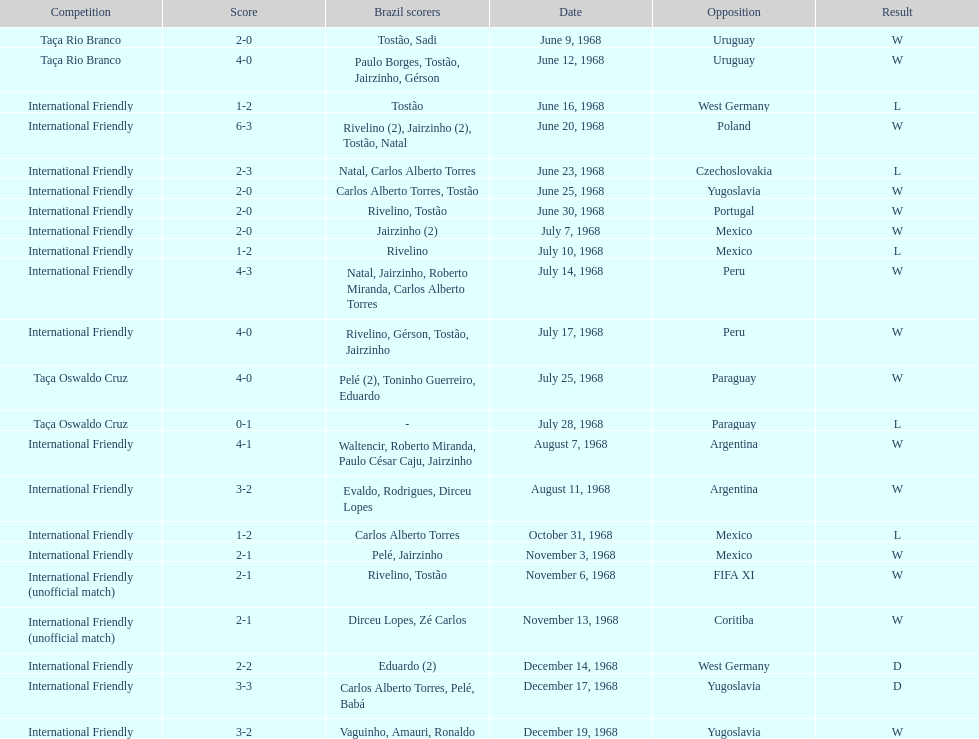The most goals scored by brazil in a game 6. 